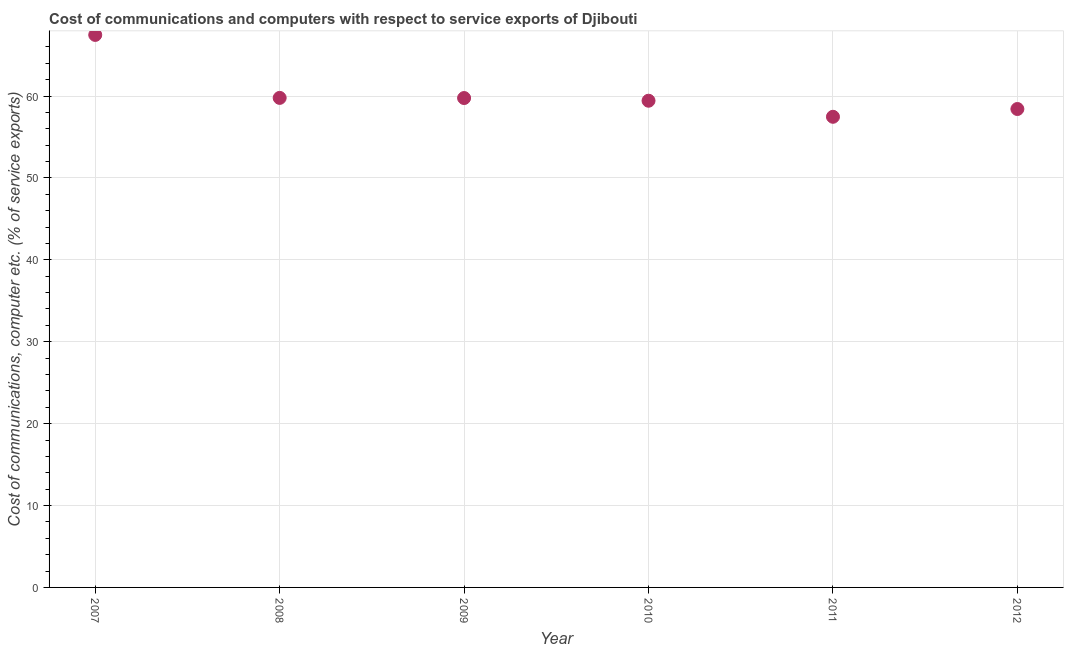What is the cost of communications and computer in 2009?
Provide a short and direct response. 59.75. Across all years, what is the maximum cost of communications and computer?
Offer a terse response. 67.46. Across all years, what is the minimum cost of communications and computer?
Provide a short and direct response. 57.47. In which year was the cost of communications and computer maximum?
Keep it short and to the point. 2007. What is the sum of the cost of communications and computer?
Provide a succinct answer. 362.3. What is the difference between the cost of communications and computer in 2010 and 2011?
Offer a terse response. 1.96. What is the average cost of communications and computer per year?
Make the answer very short. 60.38. What is the median cost of communications and computer?
Your answer should be very brief. 59.59. In how many years, is the cost of communications and computer greater than 14 %?
Your response must be concise. 6. What is the ratio of the cost of communications and computer in 2008 to that in 2009?
Keep it short and to the point. 1. What is the difference between the highest and the second highest cost of communications and computer?
Provide a short and direct response. 7.69. What is the difference between the highest and the lowest cost of communications and computer?
Keep it short and to the point. 10. In how many years, is the cost of communications and computer greater than the average cost of communications and computer taken over all years?
Offer a very short reply. 1. Does the cost of communications and computer monotonically increase over the years?
Ensure brevity in your answer.  No. What is the difference between two consecutive major ticks on the Y-axis?
Your answer should be very brief. 10. Does the graph contain grids?
Provide a short and direct response. Yes. What is the title of the graph?
Provide a short and direct response. Cost of communications and computers with respect to service exports of Djibouti. What is the label or title of the X-axis?
Provide a short and direct response. Year. What is the label or title of the Y-axis?
Your answer should be compact. Cost of communications, computer etc. (% of service exports). What is the Cost of communications, computer etc. (% of service exports) in 2007?
Make the answer very short. 67.46. What is the Cost of communications, computer etc. (% of service exports) in 2008?
Your response must be concise. 59.77. What is the Cost of communications, computer etc. (% of service exports) in 2009?
Provide a short and direct response. 59.75. What is the Cost of communications, computer etc. (% of service exports) in 2010?
Make the answer very short. 59.43. What is the Cost of communications, computer etc. (% of service exports) in 2011?
Offer a very short reply. 57.47. What is the Cost of communications, computer etc. (% of service exports) in 2012?
Ensure brevity in your answer.  58.42. What is the difference between the Cost of communications, computer etc. (% of service exports) in 2007 and 2008?
Offer a very short reply. 7.69. What is the difference between the Cost of communications, computer etc. (% of service exports) in 2007 and 2009?
Provide a short and direct response. 7.71. What is the difference between the Cost of communications, computer etc. (% of service exports) in 2007 and 2010?
Keep it short and to the point. 8.04. What is the difference between the Cost of communications, computer etc. (% of service exports) in 2007 and 2011?
Give a very brief answer. 10. What is the difference between the Cost of communications, computer etc. (% of service exports) in 2007 and 2012?
Offer a terse response. 9.05. What is the difference between the Cost of communications, computer etc. (% of service exports) in 2008 and 2009?
Ensure brevity in your answer.  0.02. What is the difference between the Cost of communications, computer etc. (% of service exports) in 2008 and 2010?
Offer a terse response. 0.35. What is the difference between the Cost of communications, computer etc. (% of service exports) in 2008 and 2011?
Your answer should be very brief. 2.31. What is the difference between the Cost of communications, computer etc. (% of service exports) in 2008 and 2012?
Your response must be concise. 1.36. What is the difference between the Cost of communications, computer etc. (% of service exports) in 2009 and 2010?
Offer a terse response. 0.33. What is the difference between the Cost of communications, computer etc. (% of service exports) in 2009 and 2011?
Provide a succinct answer. 2.29. What is the difference between the Cost of communications, computer etc. (% of service exports) in 2009 and 2012?
Offer a terse response. 1.34. What is the difference between the Cost of communications, computer etc. (% of service exports) in 2010 and 2011?
Ensure brevity in your answer.  1.96. What is the difference between the Cost of communications, computer etc. (% of service exports) in 2010 and 2012?
Make the answer very short. 1.01. What is the difference between the Cost of communications, computer etc. (% of service exports) in 2011 and 2012?
Give a very brief answer. -0.95. What is the ratio of the Cost of communications, computer etc. (% of service exports) in 2007 to that in 2008?
Your answer should be compact. 1.13. What is the ratio of the Cost of communications, computer etc. (% of service exports) in 2007 to that in 2009?
Make the answer very short. 1.13. What is the ratio of the Cost of communications, computer etc. (% of service exports) in 2007 to that in 2010?
Your answer should be compact. 1.14. What is the ratio of the Cost of communications, computer etc. (% of service exports) in 2007 to that in 2011?
Ensure brevity in your answer.  1.17. What is the ratio of the Cost of communications, computer etc. (% of service exports) in 2007 to that in 2012?
Ensure brevity in your answer.  1.16. What is the ratio of the Cost of communications, computer etc. (% of service exports) in 2008 to that in 2009?
Ensure brevity in your answer.  1. What is the ratio of the Cost of communications, computer etc. (% of service exports) in 2008 to that in 2010?
Keep it short and to the point. 1.01. What is the ratio of the Cost of communications, computer etc. (% of service exports) in 2008 to that in 2011?
Offer a very short reply. 1.04. What is the ratio of the Cost of communications, computer etc. (% of service exports) in 2008 to that in 2012?
Ensure brevity in your answer.  1.02. What is the ratio of the Cost of communications, computer etc. (% of service exports) in 2009 to that in 2010?
Make the answer very short. 1.01. What is the ratio of the Cost of communications, computer etc. (% of service exports) in 2010 to that in 2011?
Provide a short and direct response. 1.03. 